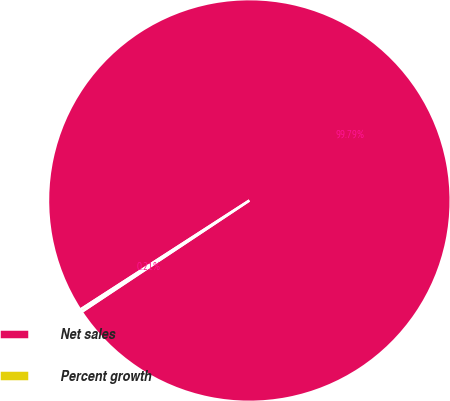<chart> <loc_0><loc_0><loc_500><loc_500><pie_chart><fcel>Net sales<fcel>Percent growth<nl><fcel>99.79%<fcel>0.21%<nl></chart> 